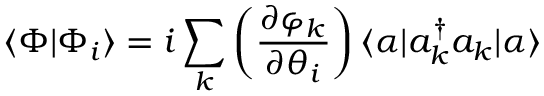<formula> <loc_0><loc_0><loc_500><loc_500>\langle \Phi | \Phi _ { i } \rangle = i \sum _ { k } \left ( \frac { \partial \varphi _ { k } } { \partial \theta _ { i } } \right ) \langle \alpha | a _ { k } ^ { \dagger } a _ { k } | \alpha \rangle</formula> 